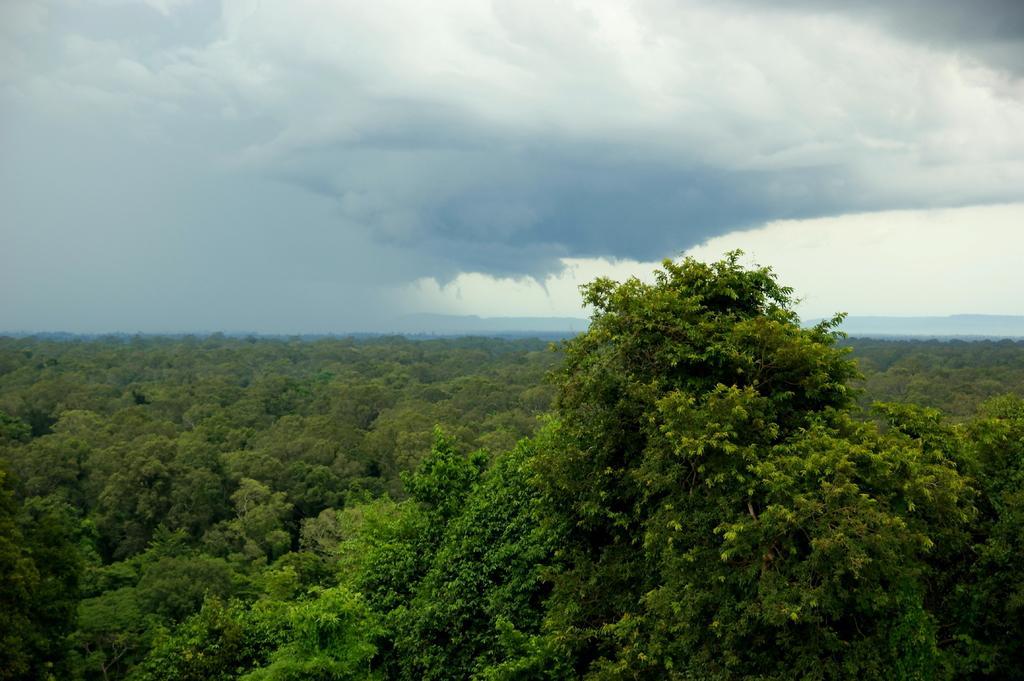Can you describe this image briefly? This is an aerial view. In this picture we can see the trees and clouds are present in the sky. 